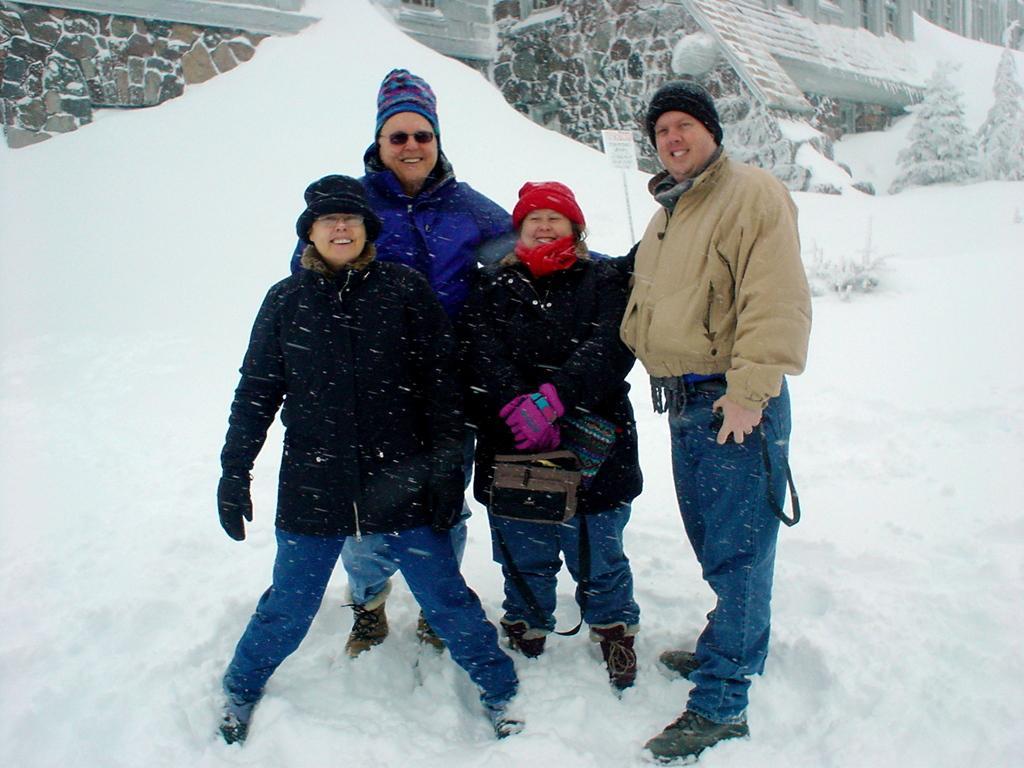How would you summarize this image in a sentence or two? In this picture we can see people standing on snow, one person is holding a bag and in the background we can see a name board, plants and buildings. 